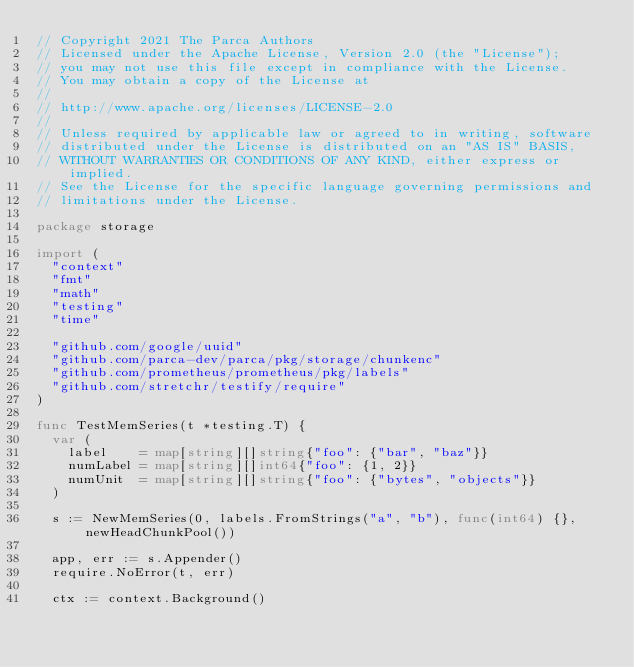<code> <loc_0><loc_0><loc_500><loc_500><_Go_>// Copyright 2021 The Parca Authors
// Licensed under the Apache License, Version 2.0 (the "License");
// you may not use this file except in compliance with the License.
// You may obtain a copy of the License at
//
// http://www.apache.org/licenses/LICENSE-2.0
//
// Unless required by applicable law or agreed to in writing, software
// distributed under the License is distributed on an "AS IS" BASIS,
// WITHOUT WARRANTIES OR CONDITIONS OF ANY KIND, either express or implied.
// See the License for the specific language governing permissions and
// limitations under the License.

package storage

import (
	"context"
	"fmt"
	"math"
	"testing"
	"time"

	"github.com/google/uuid"
	"github.com/parca-dev/parca/pkg/storage/chunkenc"
	"github.com/prometheus/prometheus/pkg/labels"
	"github.com/stretchr/testify/require"
)

func TestMemSeries(t *testing.T) {
	var (
		label    = map[string][]string{"foo": {"bar", "baz"}}
		numLabel = map[string][]int64{"foo": {1, 2}}
		numUnit  = map[string][]string{"foo": {"bytes", "objects"}}
	)

	s := NewMemSeries(0, labels.FromStrings("a", "b"), func(int64) {}, newHeadChunkPool())

	app, err := s.Appender()
	require.NoError(t, err)

	ctx := context.Background()
</code> 